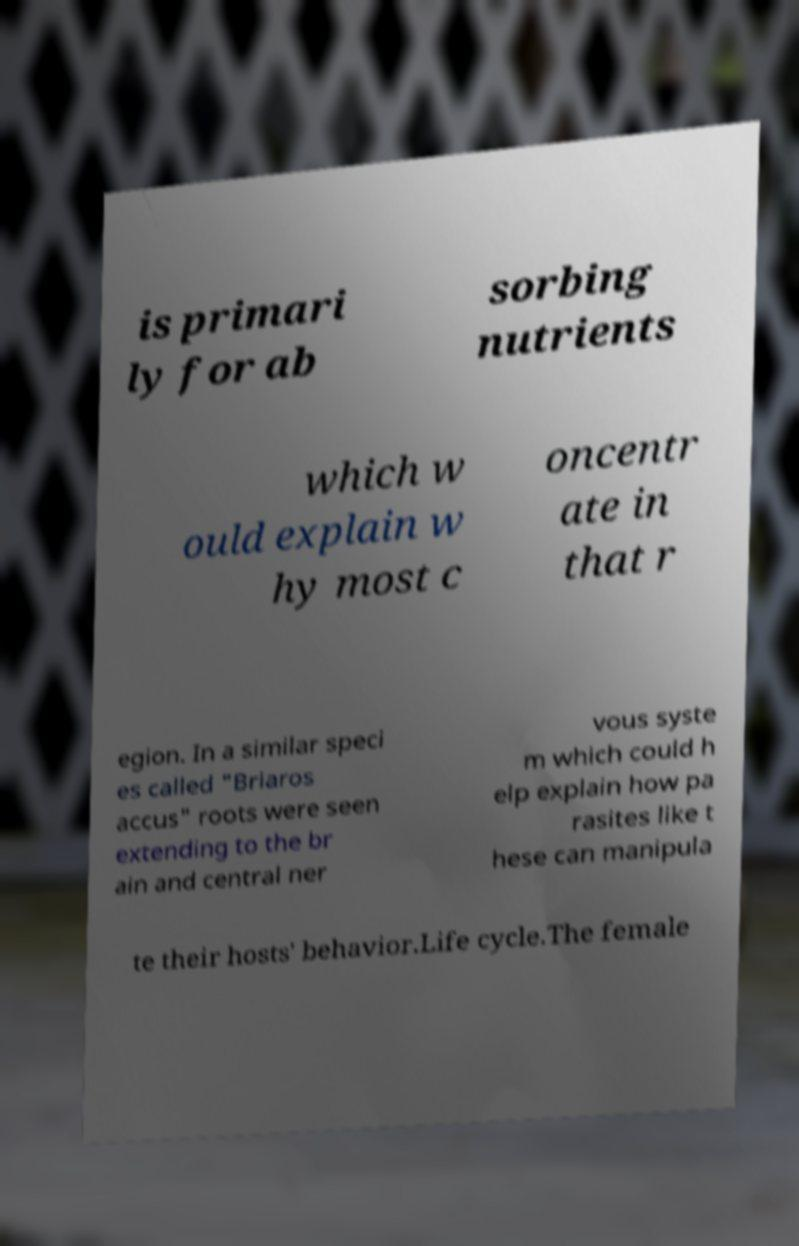For documentation purposes, I need the text within this image transcribed. Could you provide that? is primari ly for ab sorbing nutrients which w ould explain w hy most c oncentr ate in that r egion. In a similar speci es called "Briaros accus" roots were seen extending to the br ain and central ner vous syste m which could h elp explain how pa rasites like t hese can manipula te their hosts' behavior.Life cycle.The female 